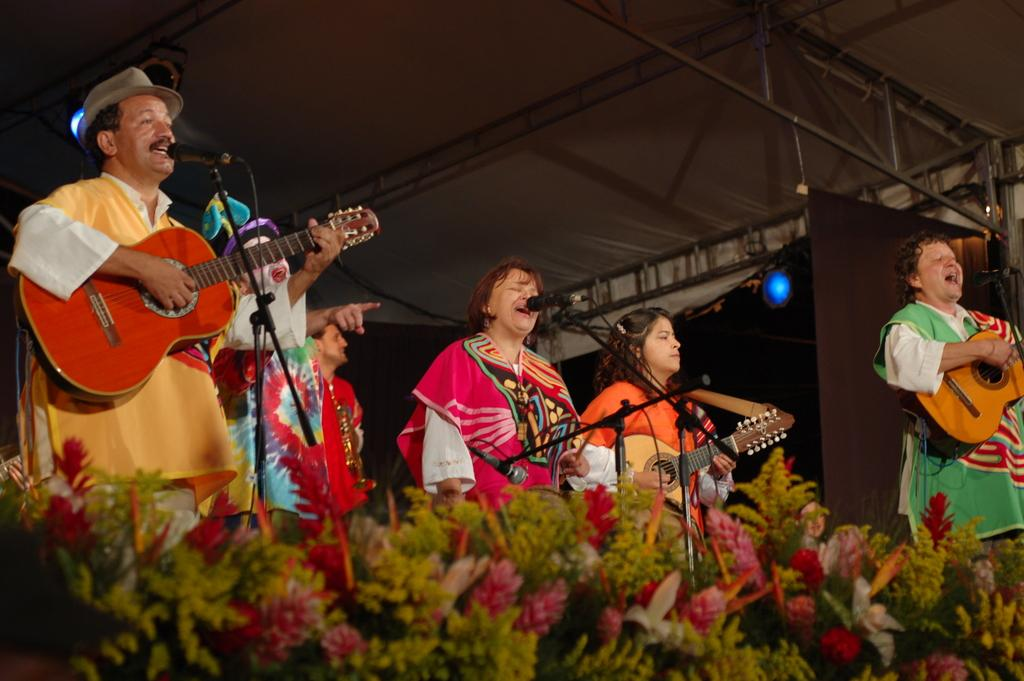How many people are in the image? There is a group of persons in the image. What are the people in the image doing? The group of persons are playing music and singing. What device is present in the image that might be used for amplifying sound? There is a microphone in the image. What type of tin can be seen being woven with thread in the image? There is no tin or thread present in the image; the group of persons are playing music and singing. 